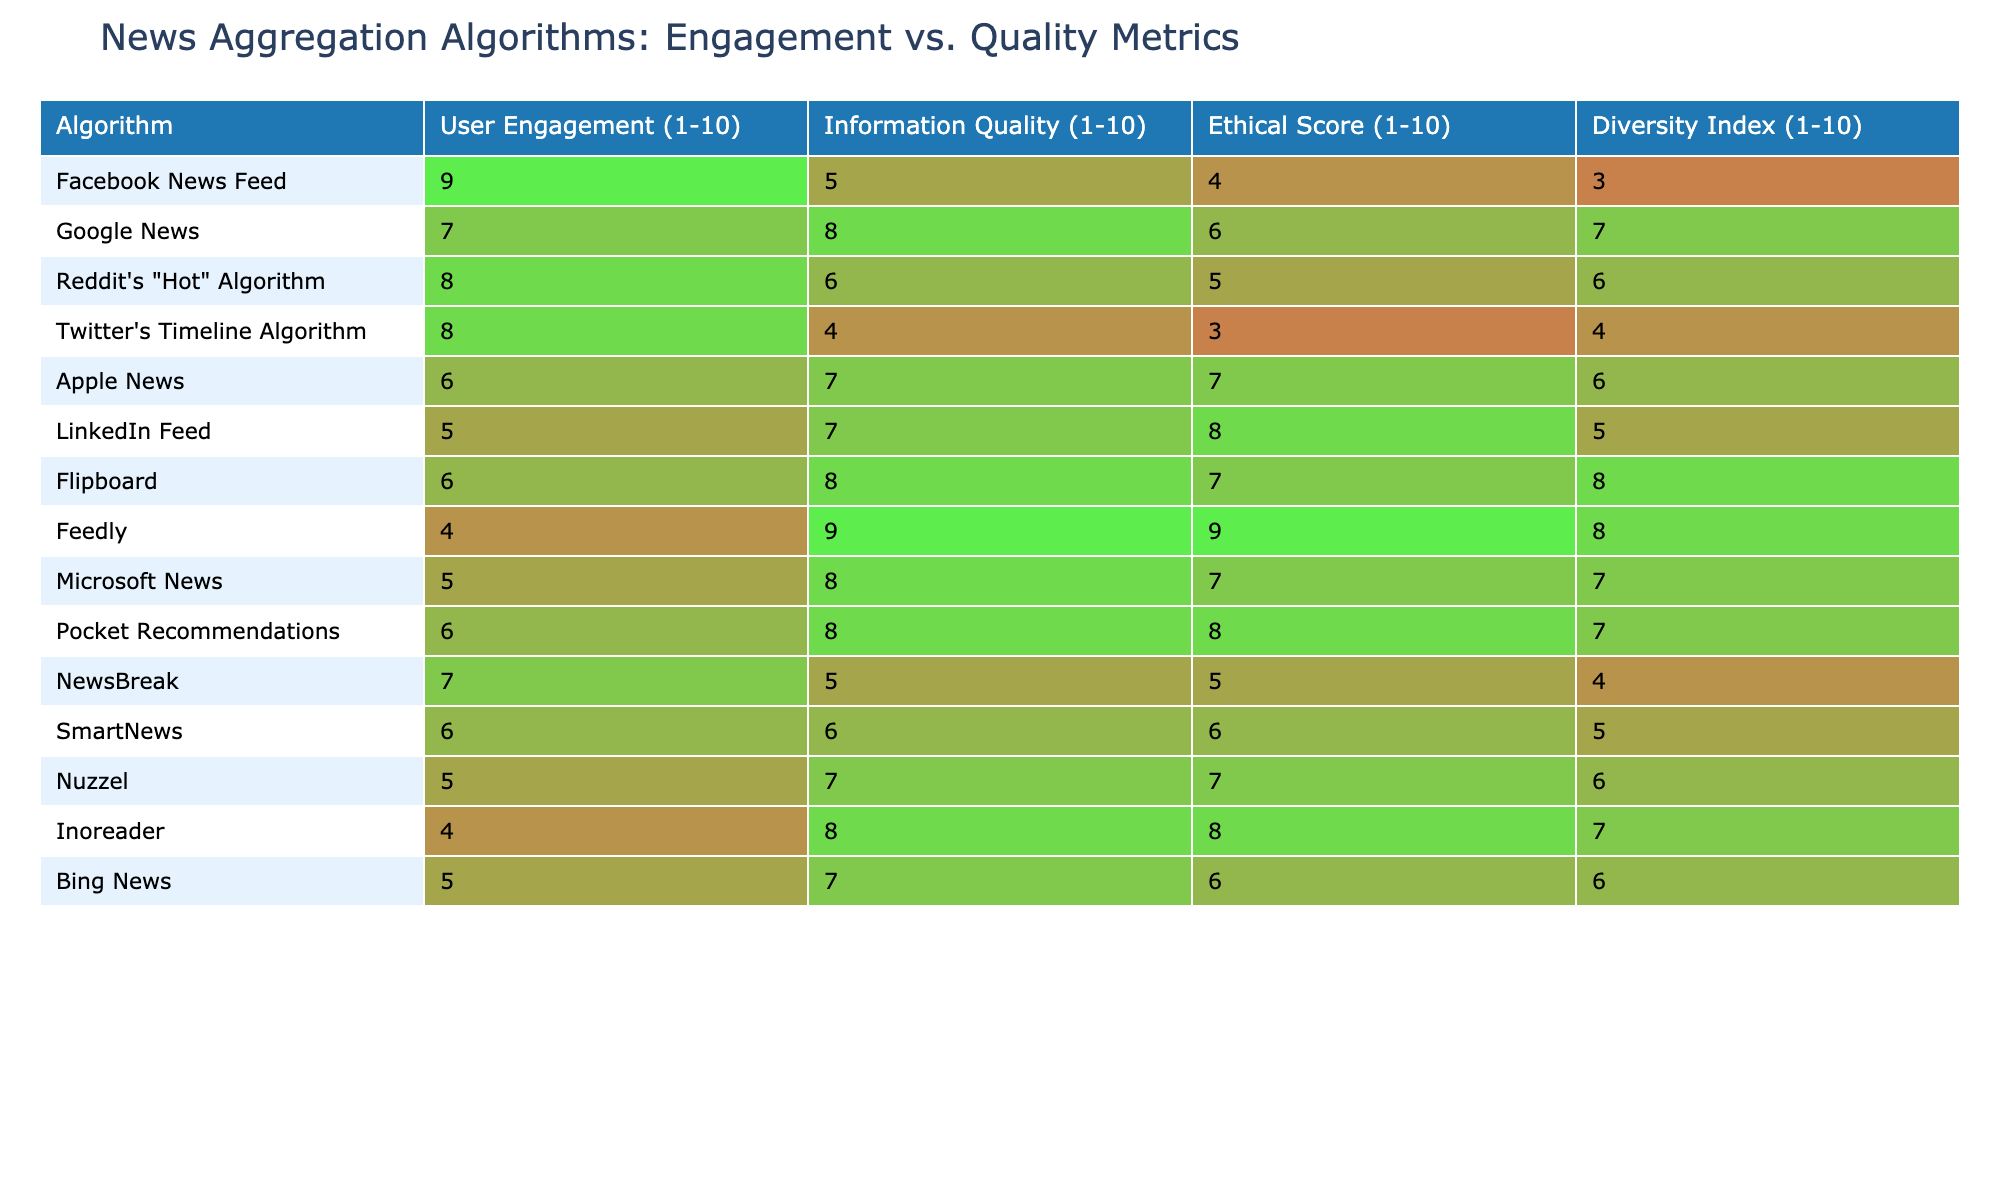What is the highest user engagement score in the table? By examining the "User Engagement" column, the highest value is 9, which corresponds to Facebook News Feed.
Answer: 9 Which algorithm has the highest information quality score? Looking at the "Information Quality" column, Feedly has the highest score of 9.
Answer: Feedly What is the average ethical score of all algorithms listed? The ethical scores are: 4, 6, 5, 3, 7, 8, 7, 9, 8, 5, 6, 6, 7, 8, 6. Summing them gives 81 and dividing by 15 algorithms gives an average of 5.4.
Answer: 5.4 Which algorithm has the lowest diversity index? In the "Diversity Index" column, the lowest score is 3, which belongs to Facebook News Feed.
Answer: Facebook News Feed Is there any algorithm with a user engagement score above 8 and an information quality score below 6? Checking the table, Facebook News Feed has a user engagement score of 9 but an information quality score of 5. Thus, it meets the criteria.
Answer: Yes How many algorithms have both a user engagement score and an information quality score of 6 or higher? Counting the algorithms that have scores of 6 or higher for both metrics, we find 8 algorithms satisfy this condition (Google News, Reddit's "Hot" Algorithm, Apple News, Flipboard, Feedly, Microsoft News, Pocket Recommendations, and Nuzzel).
Answer: 8 What is the difference between the highest and lowest information quality scores? The highest score (Feedly) is 9, and the lowest score (Twitter's Timeline Algorithm) is 4. The difference is 9 - 4 = 5.
Answer: 5 Which two algorithms have the same ethical score of 7? In the ethical score column, Apple News and Pocket Recommendations both have a score of 7.
Answer: Apple News and Pocket Recommendations Can you identify any algorithm that has a user engagement score of 5 but a diversity index of 7 or higher? Examining the table reveals that the LinkedIn Feed has a user engagement score of 5 and a diversity index of 7.
Answer: LinkedIn Feed Among the algorithms with the highest ethical scores, which one has the lowest user engagement score? The algorithms with the highest ethical score of 9 are Feedly and Inoreader, but Feedly has a higher engagement score (4) than Inoreader (4). Thus, the answer remains Inoreader.
Answer: Inoreader 